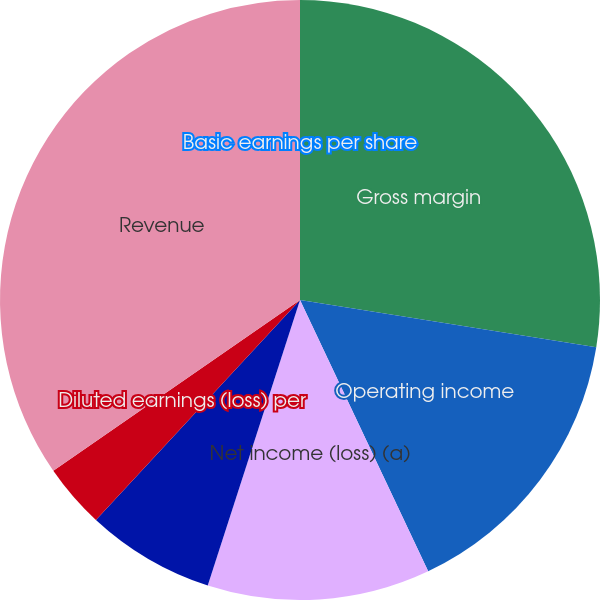Convert chart to OTSL. <chart><loc_0><loc_0><loc_500><loc_500><pie_chart><fcel>Gross margin<fcel>Operating income<fcel>Net income (loss) (a)<fcel>Basic earnings (loss) per<fcel>Diluted earnings (loss) per<fcel>Revenue<fcel>Basic earnings per share<nl><fcel>27.51%<fcel>15.46%<fcel>12.0%<fcel>6.93%<fcel>3.46%<fcel>34.63%<fcel>0.0%<nl></chart> 